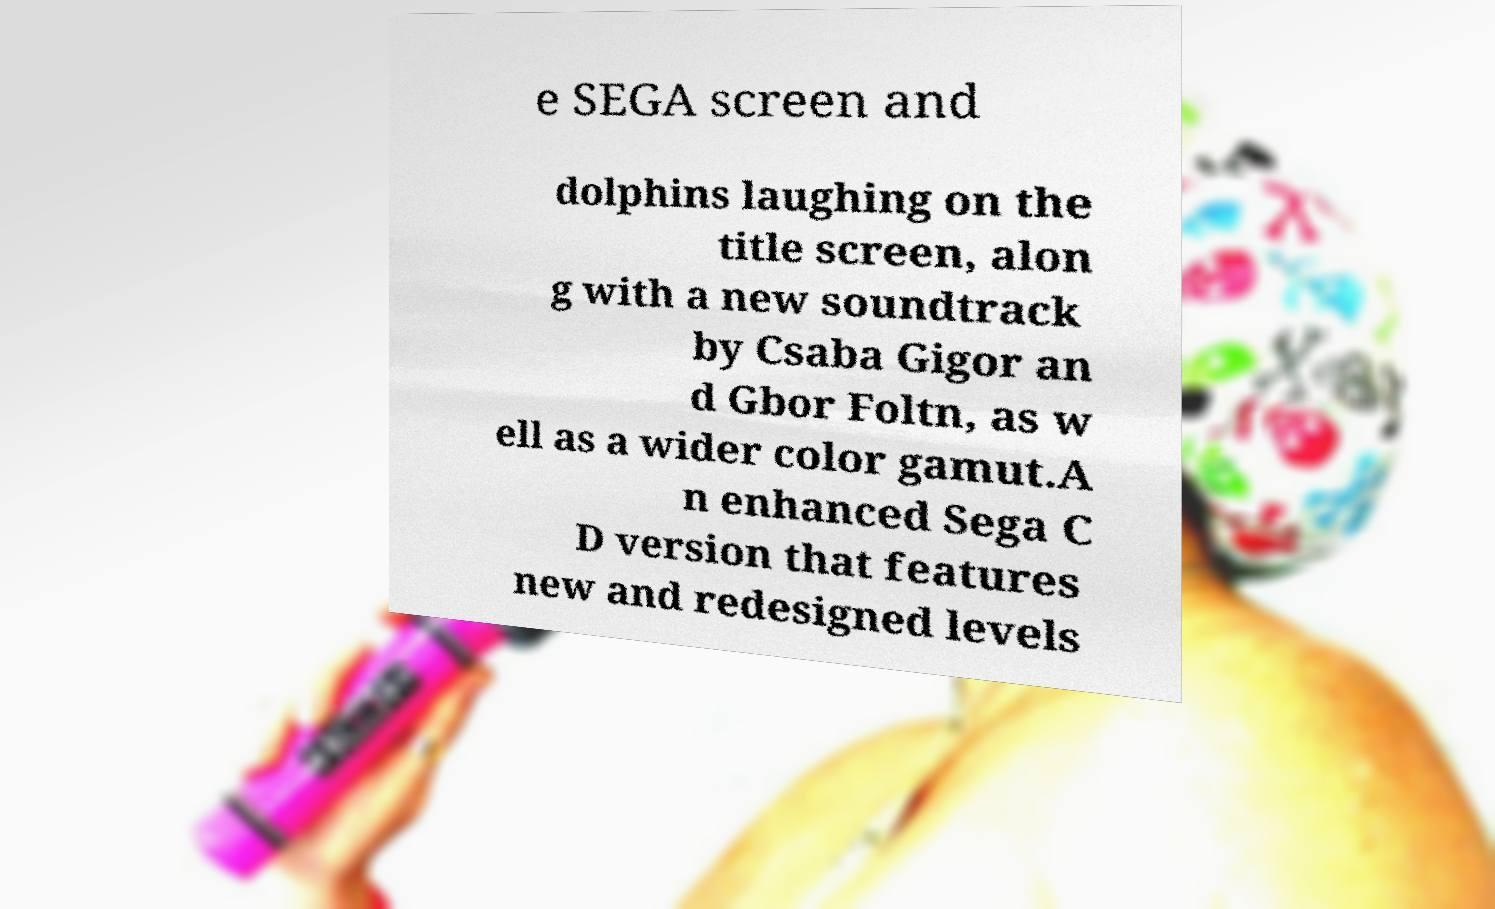I need the written content from this picture converted into text. Can you do that? e SEGA screen and dolphins laughing on the title screen, alon g with a new soundtrack by Csaba Gigor an d Gbor Foltn, as w ell as a wider color gamut.A n enhanced Sega C D version that features new and redesigned levels 